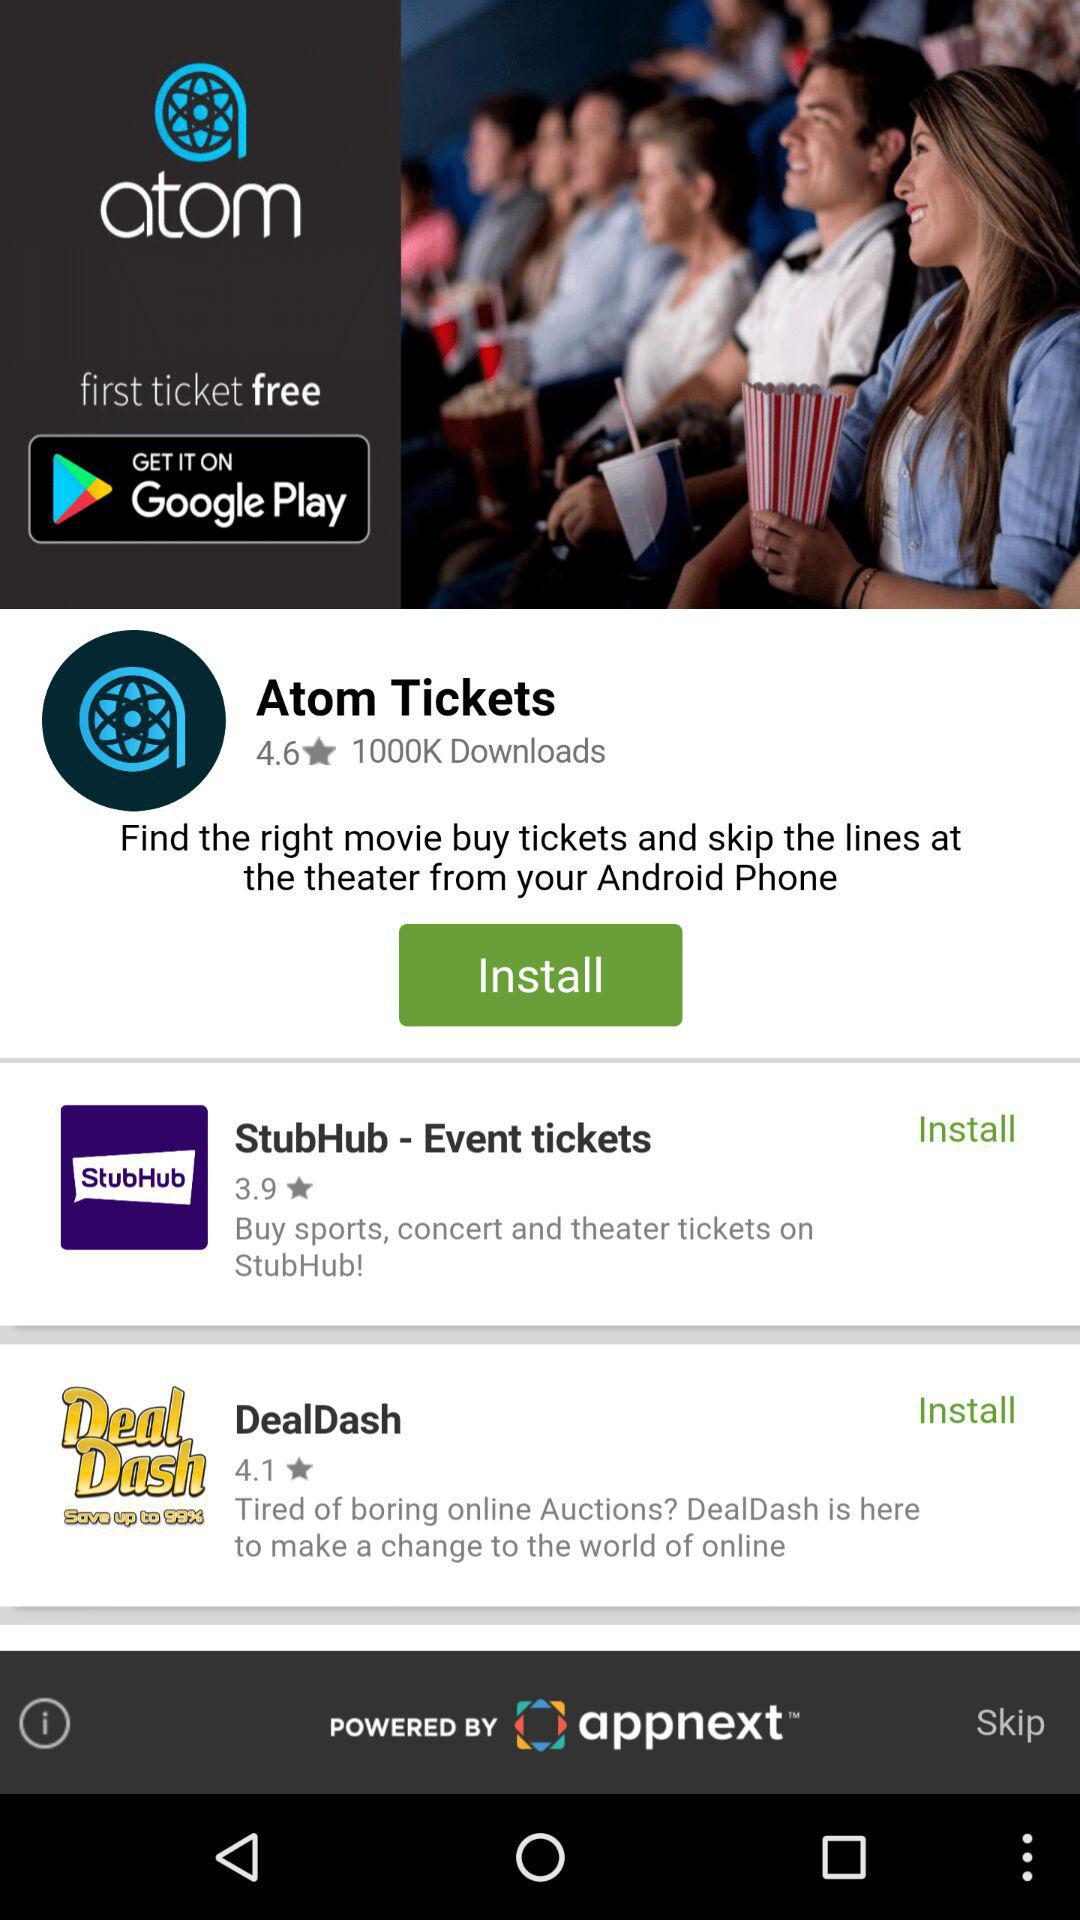What application should we download when we're bored with the online auction? The application is "DealDash". 